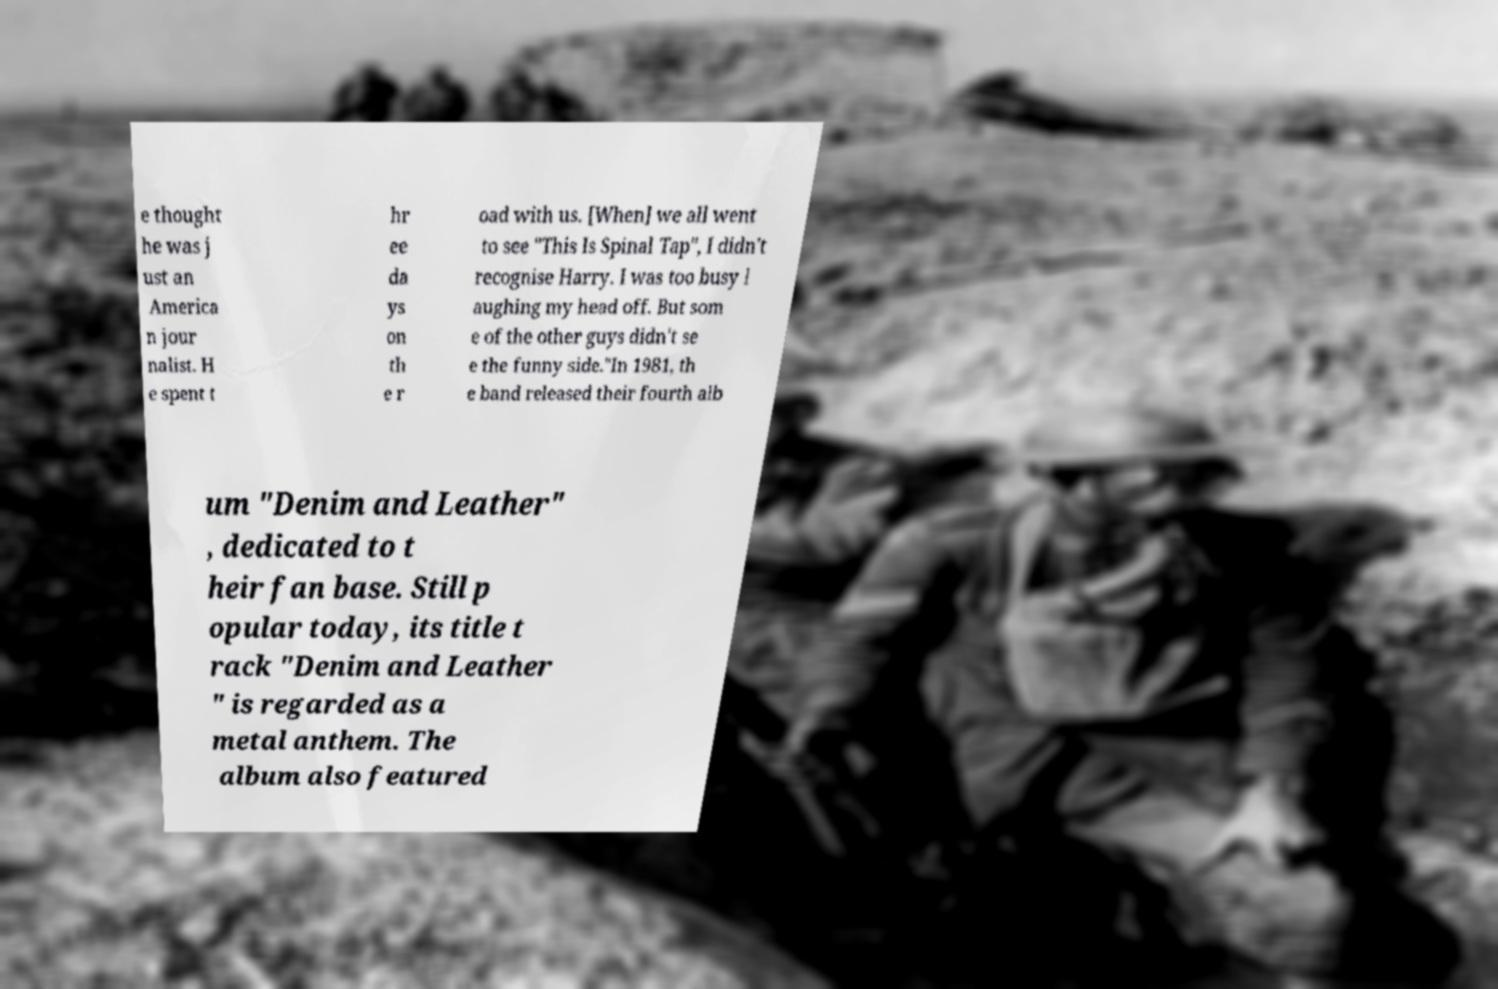Could you extract and type out the text from this image? e thought he was j ust an America n jour nalist. H e spent t hr ee da ys on th e r oad with us. [When] we all went to see "This Is Spinal Tap", I didn't recognise Harry. I was too busy l aughing my head off. But som e of the other guys didn't se e the funny side."In 1981, th e band released their fourth alb um "Denim and Leather" , dedicated to t heir fan base. Still p opular today, its title t rack "Denim and Leather " is regarded as a metal anthem. The album also featured 